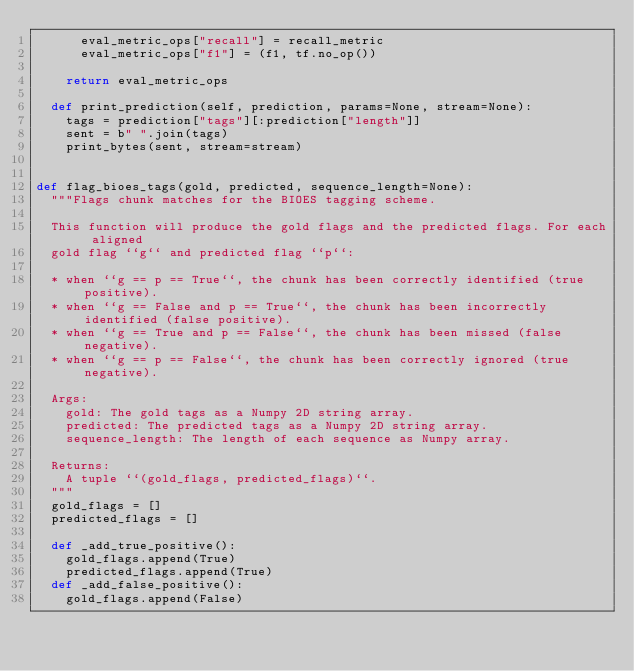<code> <loc_0><loc_0><loc_500><loc_500><_Python_>      eval_metric_ops["recall"] = recall_metric
      eval_metric_ops["f1"] = (f1, tf.no_op())

    return eval_metric_ops

  def print_prediction(self, prediction, params=None, stream=None):
    tags = prediction["tags"][:prediction["length"]]
    sent = b" ".join(tags)
    print_bytes(sent, stream=stream)


def flag_bioes_tags(gold, predicted, sequence_length=None):
  """Flags chunk matches for the BIOES tagging scheme.

  This function will produce the gold flags and the predicted flags. For each aligned
  gold flag ``g`` and predicted flag ``p``:

  * when ``g == p == True``, the chunk has been correctly identified (true positive).
  * when ``g == False and p == True``, the chunk has been incorrectly identified (false positive).
  * when ``g == True and p == False``, the chunk has been missed (false negative).
  * when ``g == p == False``, the chunk has been correctly ignored (true negative).

  Args:
    gold: The gold tags as a Numpy 2D string array.
    predicted: The predicted tags as a Numpy 2D string array.
    sequence_length: The length of each sequence as Numpy array.

  Returns:
    A tuple ``(gold_flags, predicted_flags)``.
  """
  gold_flags = []
  predicted_flags = []

  def _add_true_positive():
    gold_flags.append(True)
    predicted_flags.append(True)
  def _add_false_positive():
    gold_flags.append(False)</code> 